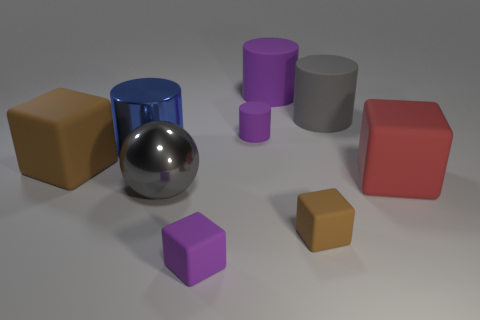Subtract all gray spheres. How many purple cylinders are left? 2 Subtract all purple cubes. How many cubes are left? 3 Subtract all small rubber cylinders. How many cylinders are left? 3 Subtract all spheres. How many objects are left? 8 Subtract all blue cubes. Subtract all green balls. How many cubes are left? 4 Add 4 tiny cyan blocks. How many tiny cyan blocks exist? 4 Subtract 1 purple blocks. How many objects are left? 8 Subtract all small purple metal cylinders. Subtract all small purple rubber blocks. How many objects are left? 8 Add 1 gray rubber cylinders. How many gray rubber cylinders are left? 2 